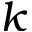Convert formula to latex. <formula><loc_0><loc_0><loc_500><loc_500>k</formula> 